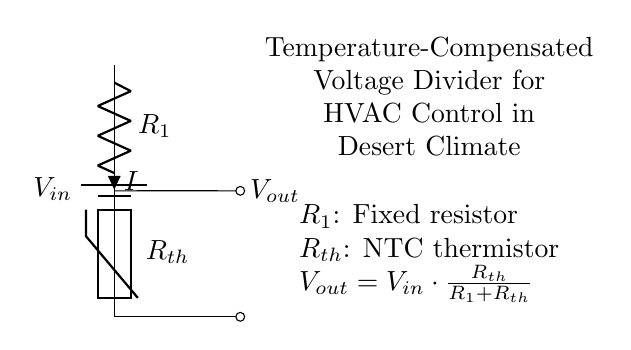What are the components in this voltage divider? The circuit includes a battery, a fixed resistor labeled R1, and an NTC thermistor labeled Rth.
Answer: Battery, R1, Rth What is the purpose of the thermistor in this circuit? The NTC thermistor Rth is used to change resistance with temperature, allowing for temperature compensation in the voltage divider.
Answer: Temperature compensation What is the output voltage expression in this circuit? The output voltage is represented by the formula Vout equals Vin multiplied by Rth divided by the sum of R1 and Rth.
Answer: Vout = Vin * Rth / (R1 + Rth) How does the temperature affect the output voltage? As temperature increases, the resistance of the NTC thermistor decreases, leading to a change in output voltage according to the voltage divider formula.
Answer: Inversely proportional What is the significance of using a fixed resistor R1 in this circuit? The fixed resistor R1 provides a stable reference point for the voltage divider equation, ensuring predictable behavior as temperature changes.
Answer: Stability What happens to Vout if R1 is significantly larger than Rth? If R1 is much larger, Vout will be small, as the voltage will mainly drop across R1, making the thermistor's influence negligible.
Answer: Vout will be small What overall function does this circuit serve in HVAC control? This voltage divider circuit helps to accurately control HVAC systems by adjusting output voltage based on temperature, ensuring optimal performance in a desert climate.
Answer: HVAC control 